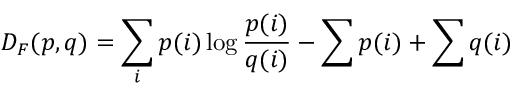<formula> <loc_0><loc_0><loc_500><loc_500>D _ { F } ( p , q ) = \sum _ { i } p ( i ) \log { \frac { p ( i ) } { q ( i ) } } - \sum p ( i ) + \sum q ( i )</formula> 